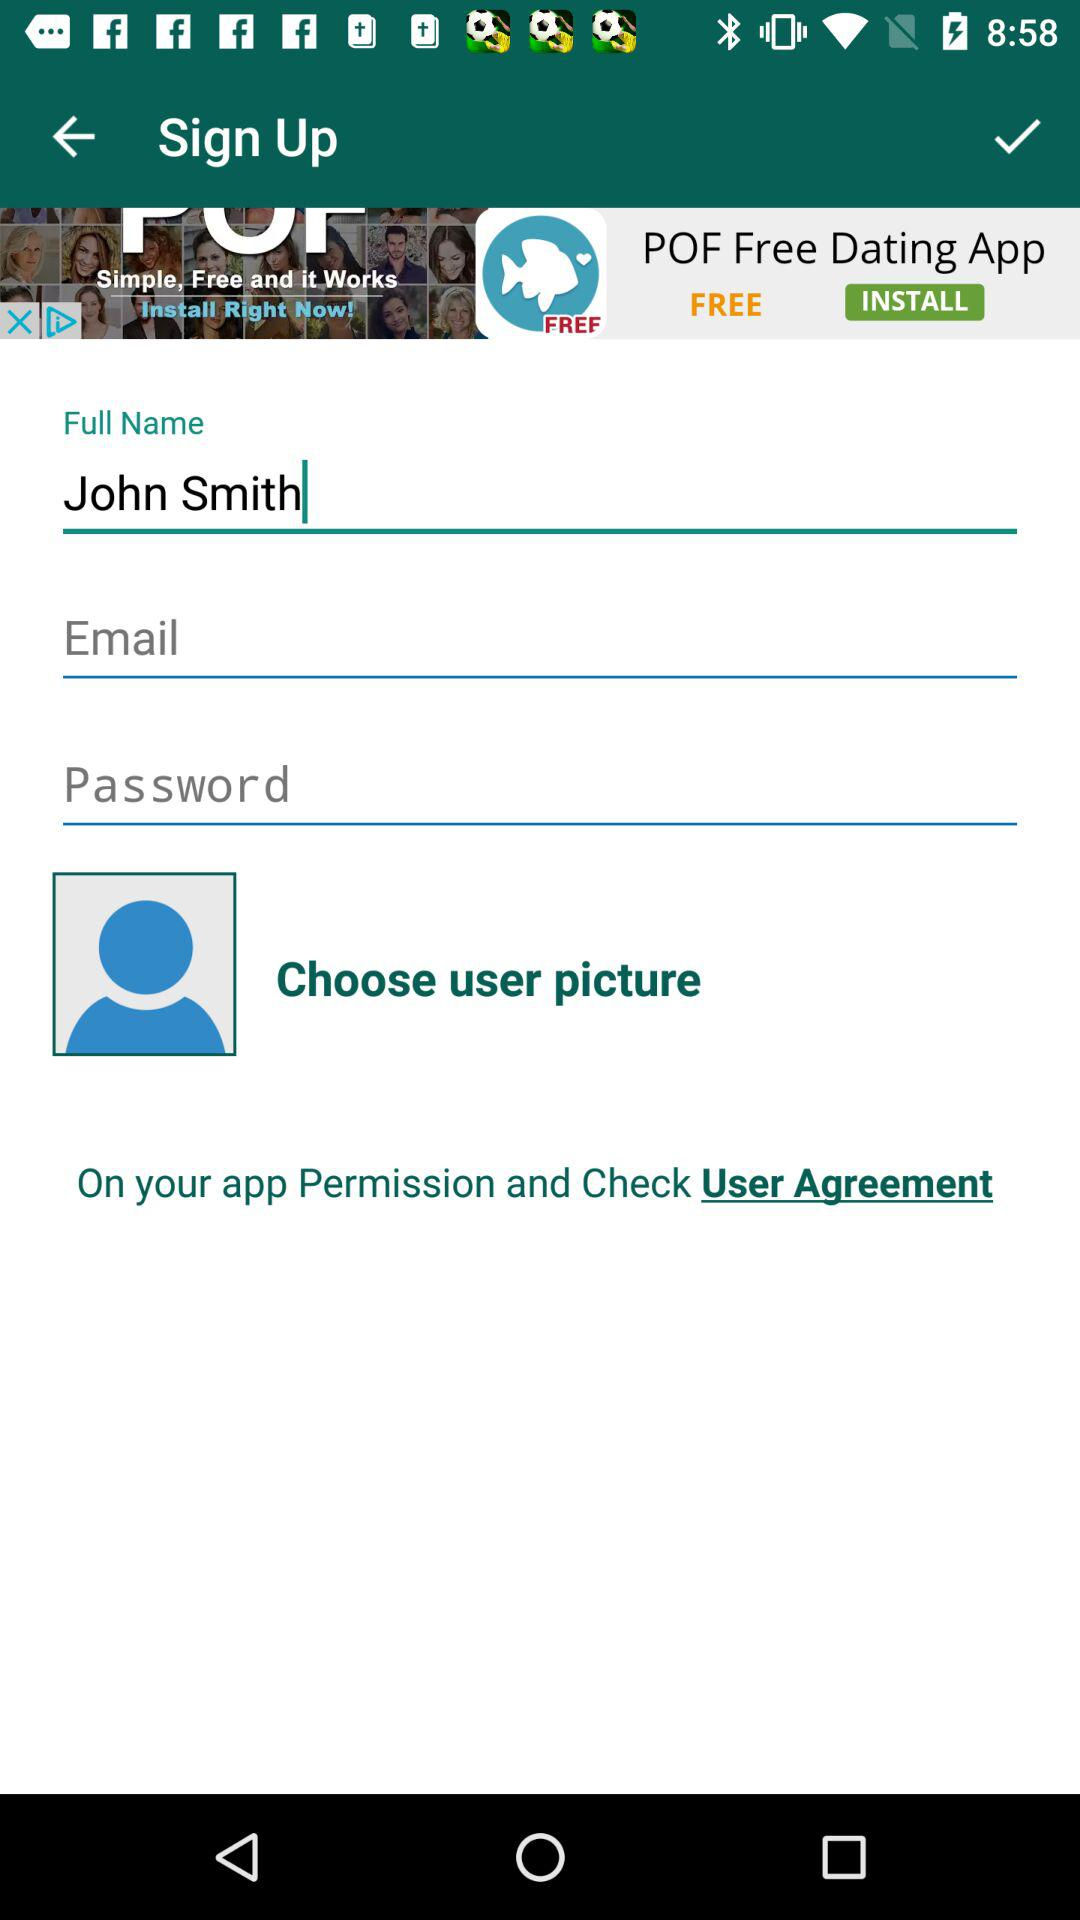How many input fields are required for signing up?
Answer the question using a single word or phrase. 3 